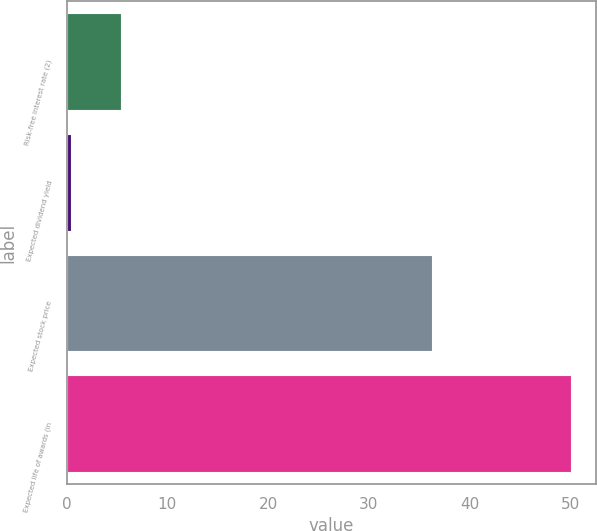Convert chart to OTSL. <chart><loc_0><loc_0><loc_500><loc_500><bar_chart><fcel>Risk-free interest rate (2)<fcel>Expected dividend yield<fcel>Expected stock price<fcel>Expected life of awards (in<nl><fcel>5.36<fcel>0.4<fcel>36.3<fcel>50<nl></chart> 